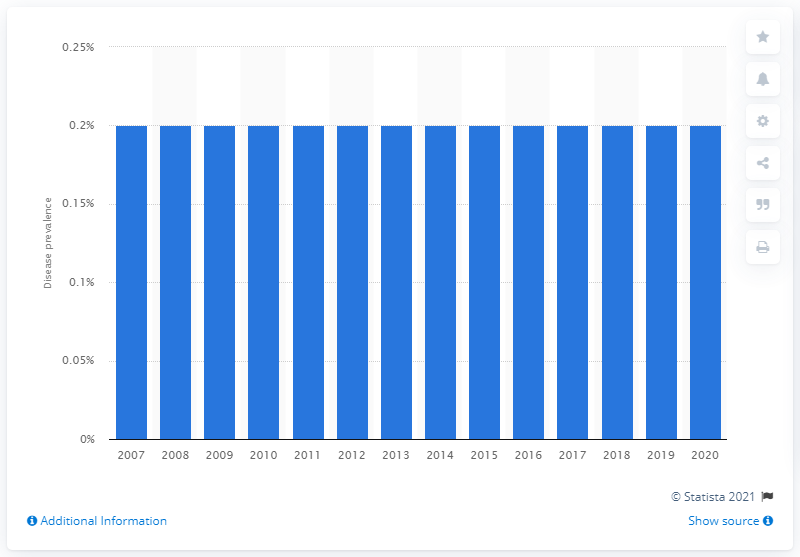Outline some significant characteristics in this image. The prevalence of type 1 diabetes among adults in the United States in 2020 is estimated to be 0.2%. 